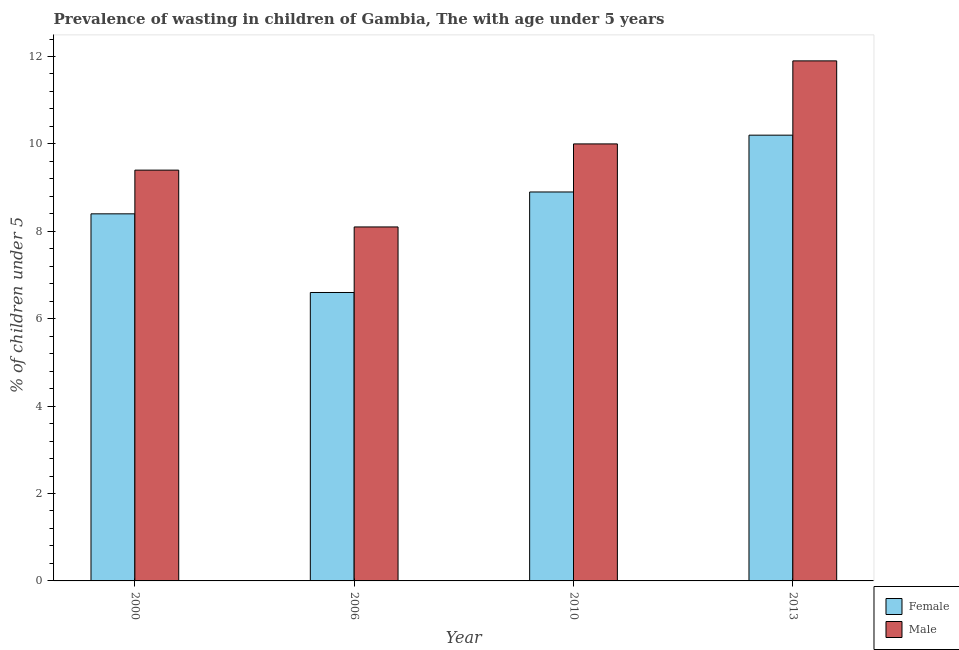How many groups of bars are there?
Offer a terse response. 4. Are the number of bars on each tick of the X-axis equal?
Offer a terse response. Yes. How many bars are there on the 3rd tick from the left?
Provide a succinct answer. 2. How many bars are there on the 4th tick from the right?
Provide a short and direct response. 2. What is the label of the 3rd group of bars from the left?
Give a very brief answer. 2010. In how many cases, is the number of bars for a given year not equal to the number of legend labels?
Keep it short and to the point. 0. What is the percentage of undernourished male children in 2013?
Your answer should be compact. 11.9. Across all years, what is the maximum percentage of undernourished male children?
Your response must be concise. 11.9. Across all years, what is the minimum percentage of undernourished female children?
Make the answer very short. 6.6. In which year was the percentage of undernourished female children maximum?
Ensure brevity in your answer.  2013. In which year was the percentage of undernourished female children minimum?
Provide a succinct answer. 2006. What is the total percentage of undernourished female children in the graph?
Make the answer very short. 34.1. What is the difference between the percentage of undernourished female children in 2000 and that in 2013?
Your answer should be very brief. -1.8. What is the difference between the percentage of undernourished male children in 2006 and the percentage of undernourished female children in 2000?
Offer a terse response. -1.3. What is the average percentage of undernourished female children per year?
Your response must be concise. 8.52. In how many years, is the percentage of undernourished male children greater than 4.4 %?
Your answer should be compact. 4. What is the ratio of the percentage of undernourished female children in 2000 to that in 2006?
Provide a short and direct response. 1.27. Is the difference between the percentage of undernourished male children in 2006 and 2013 greater than the difference between the percentage of undernourished female children in 2006 and 2013?
Provide a succinct answer. No. What is the difference between the highest and the second highest percentage of undernourished male children?
Offer a very short reply. 1.9. What is the difference between the highest and the lowest percentage of undernourished female children?
Provide a succinct answer. 3.6. Is the sum of the percentage of undernourished female children in 2006 and 2013 greater than the maximum percentage of undernourished male children across all years?
Ensure brevity in your answer.  Yes. What does the 2nd bar from the left in 2013 represents?
Give a very brief answer. Male. Are all the bars in the graph horizontal?
Your response must be concise. No. How many years are there in the graph?
Your answer should be compact. 4. What is the difference between two consecutive major ticks on the Y-axis?
Give a very brief answer. 2. Does the graph contain any zero values?
Keep it short and to the point. No. Does the graph contain grids?
Make the answer very short. No. Where does the legend appear in the graph?
Make the answer very short. Bottom right. What is the title of the graph?
Offer a terse response. Prevalence of wasting in children of Gambia, The with age under 5 years. What is the label or title of the X-axis?
Provide a short and direct response. Year. What is the label or title of the Y-axis?
Make the answer very short.  % of children under 5. What is the  % of children under 5 of Female in 2000?
Your response must be concise. 8.4. What is the  % of children under 5 in Male in 2000?
Your response must be concise. 9.4. What is the  % of children under 5 in Female in 2006?
Make the answer very short. 6.6. What is the  % of children under 5 of Male in 2006?
Ensure brevity in your answer.  8.1. What is the  % of children under 5 in Female in 2010?
Ensure brevity in your answer.  8.9. What is the  % of children under 5 of Male in 2010?
Your answer should be compact. 10. What is the  % of children under 5 of Female in 2013?
Provide a short and direct response. 10.2. What is the  % of children under 5 of Male in 2013?
Your response must be concise. 11.9. Across all years, what is the maximum  % of children under 5 in Female?
Your response must be concise. 10.2. Across all years, what is the maximum  % of children under 5 of Male?
Your answer should be very brief. 11.9. Across all years, what is the minimum  % of children under 5 in Female?
Provide a short and direct response. 6.6. Across all years, what is the minimum  % of children under 5 in Male?
Ensure brevity in your answer.  8.1. What is the total  % of children under 5 of Female in the graph?
Offer a very short reply. 34.1. What is the total  % of children under 5 of Male in the graph?
Offer a very short reply. 39.4. What is the difference between the  % of children under 5 of Male in 2000 and that in 2010?
Keep it short and to the point. -0.6. What is the difference between the  % of children under 5 in Female in 2000 and that in 2013?
Offer a very short reply. -1.8. What is the difference between the  % of children under 5 in Female in 2006 and that in 2013?
Your answer should be very brief. -3.6. What is the difference between the  % of children under 5 of Male in 2006 and that in 2013?
Make the answer very short. -3.8. What is the difference between the  % of children under 5 of Female in 2010 and that in 2013?
Keep it short and to the point. -1.3. What is the difference between the  % of children under 5 of Male in 2010 and that in 2013?
Give a very brief answer. -1.9. What is the difference between the  % of children under 5 of Female in 2006 and the  % of children under 5 of Male in 2010?
Your answer should be compact. -3.4. What is the difference between the  % of children under 5 of Female in 2006 and the  % of children under 5 of Male in 2013?
Ensure brevity in your answer.  -5.3. What is the average  % of children under 5 in Female per year?
Your answer should be very brief. 8.53. What is the average  % of children under 5 of Male per year?
Offer a very short reply. 9.85. In the year 2000, what is the difference between the  % of children under 5 in Female and  % of children under 5 in Male?
Ensure brevity in your answer.  -1. In the year 2006, what is the difference between the  % of children under 5 in Female and  % of children under 5 in Male?
Make the answer very short. -1.5. In the year 2010, what is the difference between the  % of children under 5 of Female and  % of children under 5 of Male?
Ensure brevity in your answer.  -1.1. In the year 2013, what is the difference between the  % of children under 5 of Female and  % of children under 5 of Male?
Offer a terse response. -1.7. What is the ratio of the  % of children under 5 in Female in 2000 to that in 2006?
Ensure brevity in your answer.  1.27. What is the ratio of the  % of children under 5 of Male in 2000 to that in 2006?
Your response must be concise. 1.16. What is the ratio of the  % of children under 5 of Female in 2000 to that in 2010?
Offer a terse response. 0.94. What is the ratio of the  % of children under 5 in Female in 2000 to that in 2013?
Provide a short and direct response. 0.82. What is the ratio of the  % of children under 5 in Male in 2000 to that in 2013?
Ensure brevity in your answer.  0.79. What is the ratio of the  % of children under 5 of Female in 2006 to that in 2010?
Provide a short and direct response. 0.74. What is the ratio of the  % of children under 5 of Male in 2006 to that in 2010?
Your answer should be compact. 0.81. What is the ratio of the  % of children under 5 in Female in 2006 to that in 2013?
Make the answer very short. 0.65. What is the ratio of the  % of children under 5 of Male in 2006 to that in 2013?
Your answer should be compact. 0.68. What is the ratio of the  % of children under 5 of Female in 2010 to that in 2013?
Your answer should be compact. 0.87. What is the ratio of the  % of children under 5 of Male in 2010 to that in 2013?
Your response must be concise. 0.84. What is the difference between the highest and the lowest  % of children under 5 in Male?
Give a very brief answer. 3.8. 